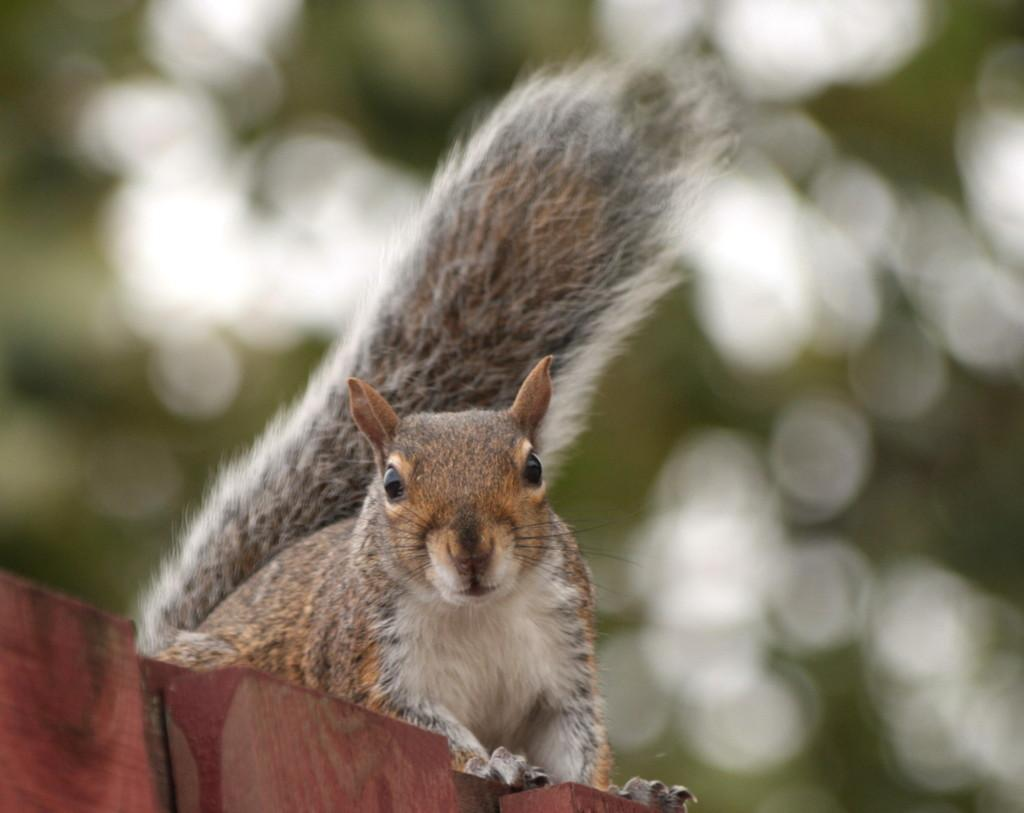What animal is present in the image? There is a squirrel in the image. Where is the squirrel located? The squirrel is on a wooden platform. Can you describe the background of the image? The background of the image is blurry. What type of jam is the squirrel spreading on the grape in the image? There is no jam or grape present in the image; it features a squirrel on a wooden platform with a blurry background. 